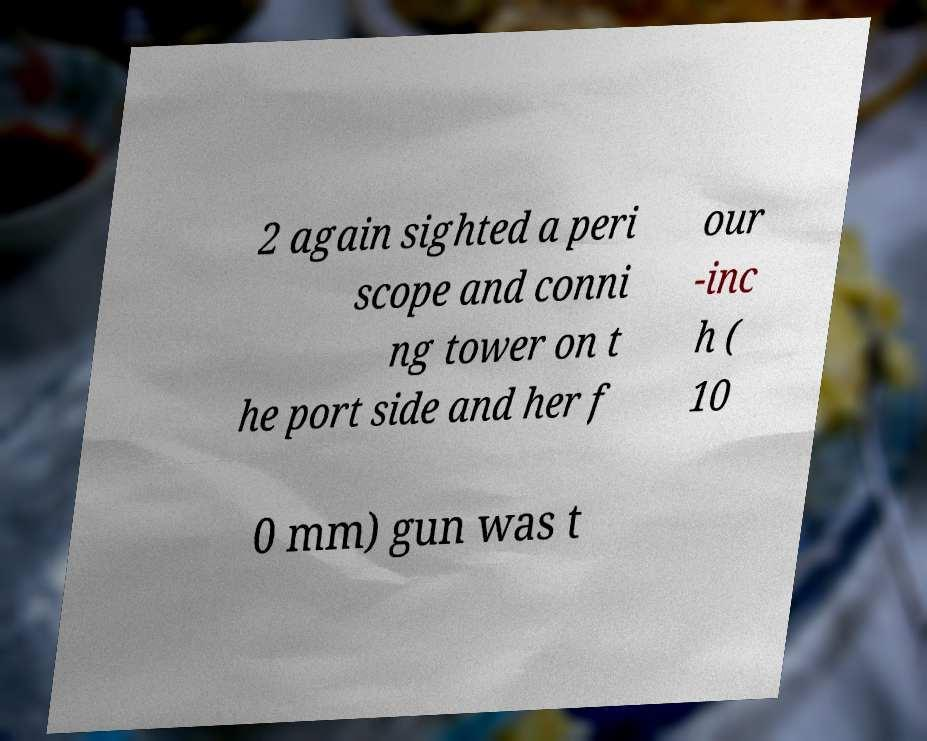Please read and relay the text visible in this image. What does it say? 2 again sighted a peri scope and conni ng tower on t he port side and her f our -inc h ( 10 0 mm) gun was t 